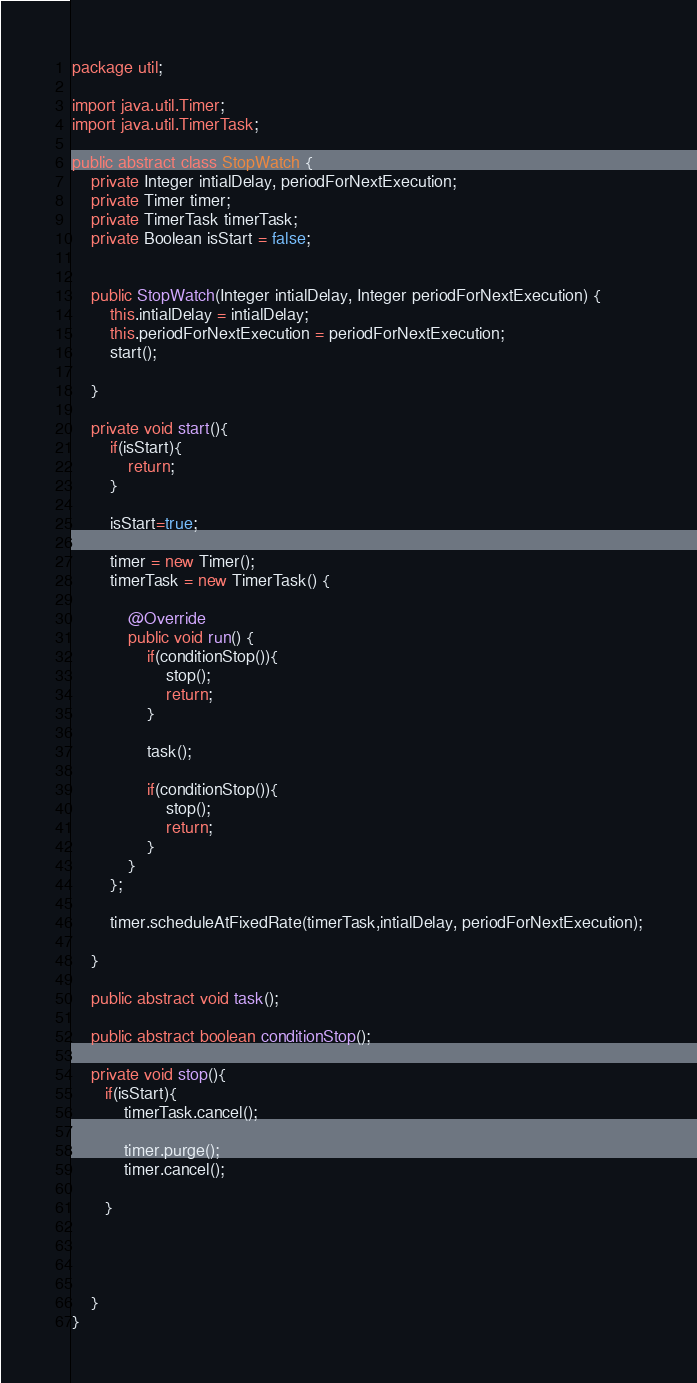<code> <loc_0><loc_0><loc_500><loc_500><_Java_>package util;

import java.util.Timer;
import java.util.TimerTask;

public abstract class StopWatch {
    private Integer intialDelay, periodForNextExecution;
    private Timer timer;
    private TimerTask timerTask;
    private Boolean isStart = false;


    public StopWatch(Integer intialDelay, Integer periodForNextExecution) {
        this.intialDelay = intialDelay;
        this.periodForNextExecution = periodForNextExecution;
        start();

    }

    private void start(){
        if(isStart){
            return;
        }

        isStart=true;

        timer = new Timer();
        timerTask = new TimerTask() {

            @Override
            public void run() {
                if(conditionStop()){
                    stop();
                    return;
                }

                task();

                if(conditionStop()){
                    stop();
                    return;
                }
            }
        };

        timer.scheduleAtFixedRate(timerTask,intialDelay, periodForNextExecution);

    }

    public abstract void task();

    public abstract boolean conditionStop();

    private void stop(){
       if(isStart){
           timerTask.cancel();

           timer.purge();
           timer.cancel();

       }




    }
}
</code> 